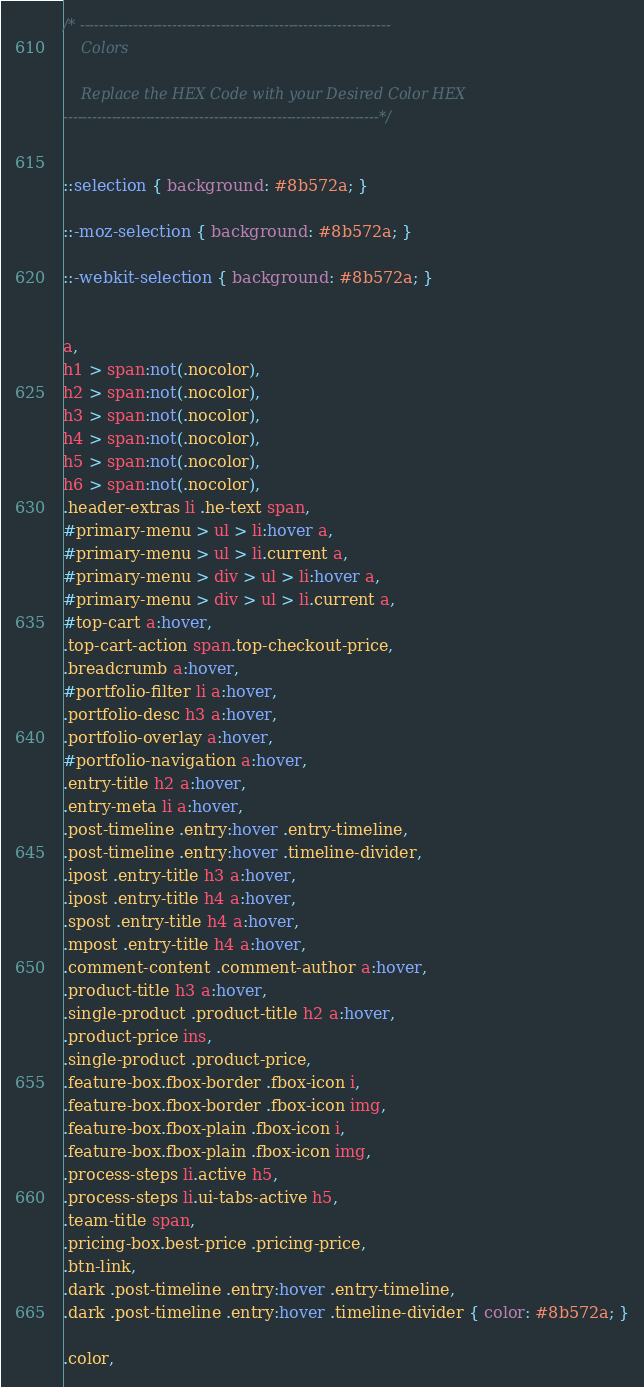<code> <loc_0><loc_0><loc_500><loc_500><_CSS_>/* ----------------------------------------------------------------
    Colors

    Replace the HEX Code with your Desired Color HEX
-----------------------------------------------------------------*/


::selection { background: #8b572a; }

::-moz-selection { background: #8b572a; }

::-webkit-selection { background: #8b572a; }


a,
h1 > span:not(.nocolor),
h2 > span:not(.nocolor),
h3 > span:not(.nocolor),
h4 > span:not(.nocolor),
h5 > span:not(.nocolor),
h6 > span:not(.nocolor),
.header-extras li .he-text span,
#primary-menu > ul > li:hover a,
#primary-menu > ul > li.current a,
#primary-menu > div > ul > li:hover a,
#primary-menu > div > ul > li.current a,
#top-cart a:hover,
.top-cart-action span.top-checkout-price,
.breadcrumb a:hover,
#portfolio-filter li a:hover,
.portfolio-desc h3 a:hover,
.portfolio-overlay a:hover,
#portfolio-navigation a:hover,
.entry-title h2 a:hover,
.entry-meta li a:hover,
.post-timeline .entry:hover .entry-timeline,
.post-timeline .entry:hover .timeline-divider,
.ipost .entry-title h3 a:hover,
.ipost .entry-title h4 a:hover,
.spost .entry-title h4 a:hover,
.mpost .entry-title h4 a:hover,
.comment-content .comment-author a:hover,
.product-title h3 a:hover,
.single-product .product-title h2 a:hover,
.product-price ins,
.single-product .product-price,
.feature-box.fbox-border .fbox-icon i,
.feature-box.fbox-border .fbox-icon img,
.feature-box.fbox-plain .fbox-icon i,
.feature-box.fbox-plain .fbox-icon img,
.process-steps li.active h5,
.process-steps li.ui-tabs-active h5,
.team-title span,
.pricing-box.best-price .pricing-price,
.btn-link,
.dark .post-timeline .entry:hover .entry-timeline,
.dark .post-timeline .entry:hover .timeline-divider { color: #8b572a; }

.color,</code> 